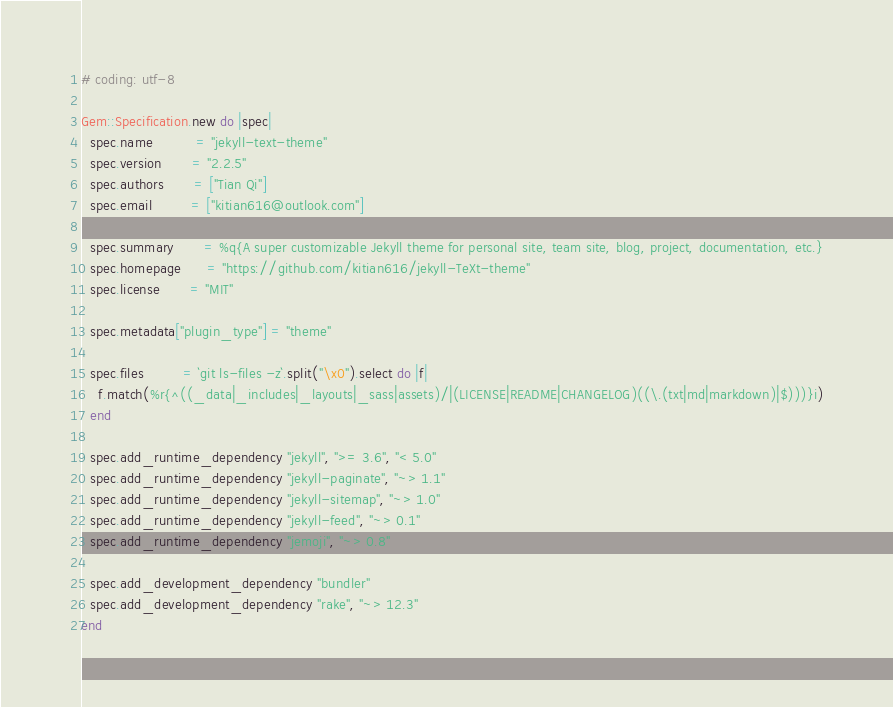Convert code to text. <code><loc_0><loc_0><loc_500><loc_500><_Ruby_># coding: utf-8

Gem::Specification.new do |spec|
  spec.name          = "jekyll-text-theme"
  spec.version       = "2.2.5"
  spec.authors       = ["Tian Qi"]
  spec.email         = ["kitian616@outlook.com"]

  spec.summary       = %q{A super customizable Jekyll theme for personal site, team site, blog, project, documentation, etc.}
  spec.homepage      = "https://github.com/kitian616/jekyll-TeXt-theme"
  spec.license       = "MIT"

  spec.metadata["plugin_type"] = "theme"

  spec.files         = `git ls-files -z`.split("\x0").select do |f|
    f.match(%r{^((_data|_includes|_layouts|_sass|assets)/|(LICENSE|README|CHANGELOG)((\.(txt|md|markdown)|$)))}i)
  end

  spec.add_runtime_dependency "jekyll", ">= 3.6", "< 5.0"
  spec.add_runtime_dependency "jekyll-paginate", "~> 1.1"
  spec.add_runtime_dependency "jekyll-sitemap", "~> 1.0"
  spec.add_runtime_dependency "jekyll-feed", "~> 0.1"
  spec.add_runtime_dependency "jemoji", "~> 0.8"

  spec.add_development_dependency "bundler"
  spec.add_development_dependency "rake", "~> 12.3"
end
</code> 